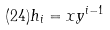Convert formula to latex. <formula><loc_0><loc_0><loc_500><loc_500>( 2 4 ) h _ { i } = x y ^ { i - 1 }</formula> 